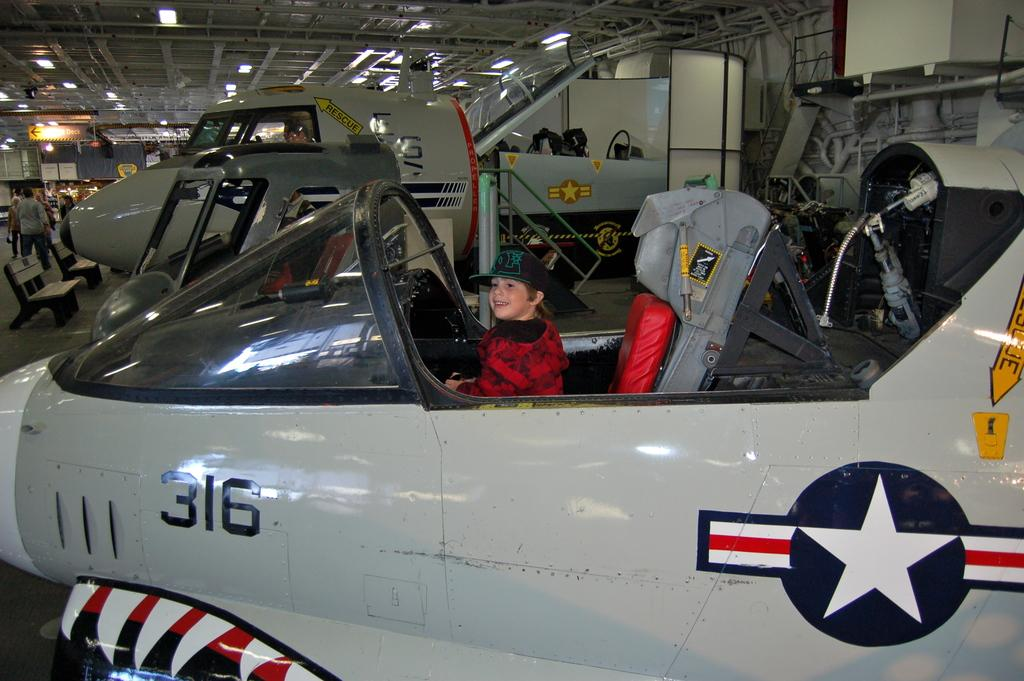<image>
Offer a succinct explanation of the picture presented. A kid sits piloting gray painted plane number 316. 